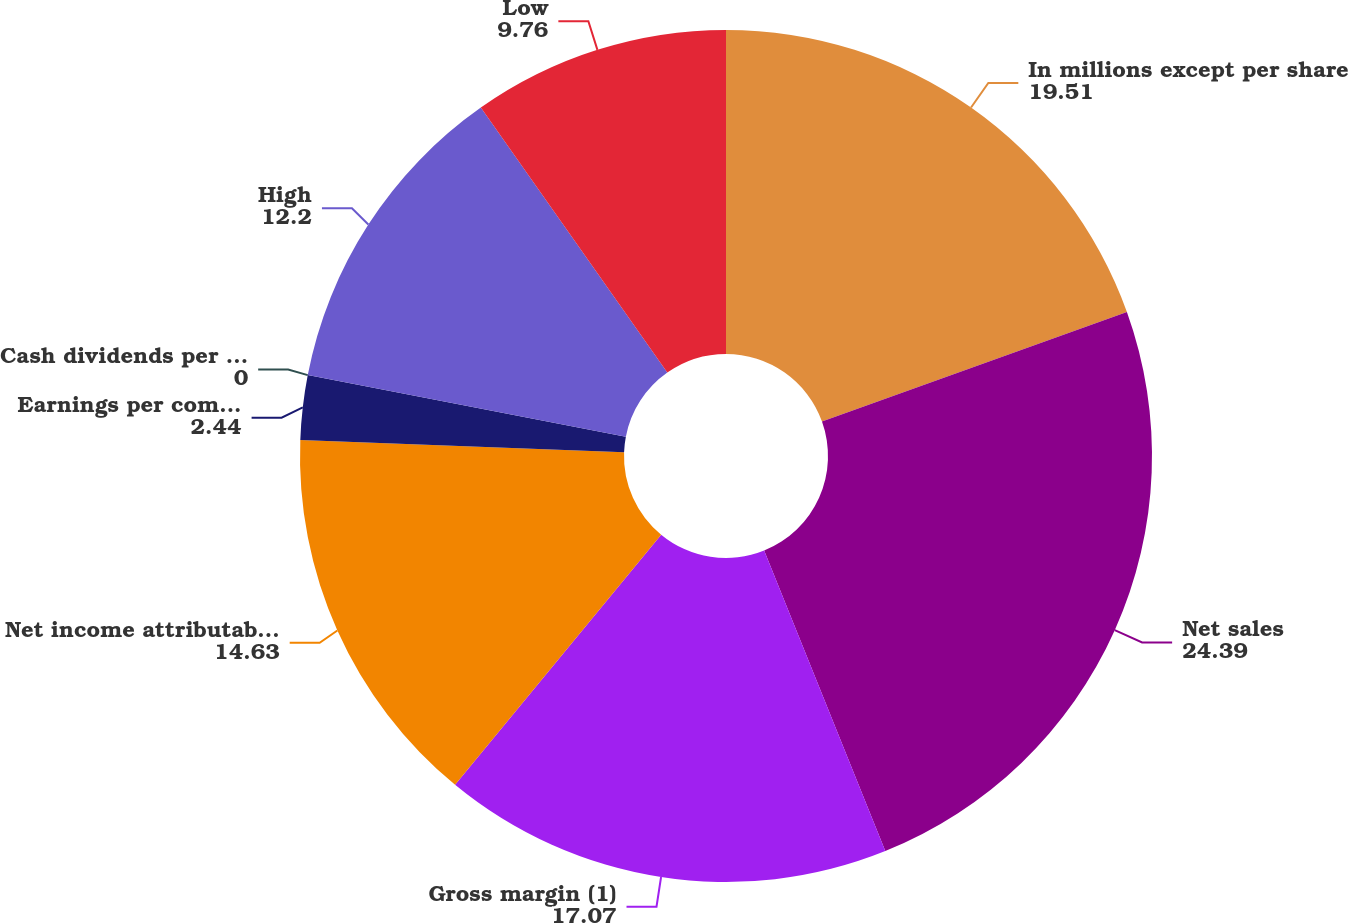Convert chart to OTSL. <chart><loc_0><loc_0><loc_500><loc_500><pie_chart><fcel>In millions except per share<fcel>Net sales<fcel>Gross margin (1)<fcel>Net income attributable to<fcel>Earnings per common share<fcel>Cash dividends per share<fcel>High<fcel>Low<nl><fcel>19.51%<fcel>24.39%<fcel>17.07%<fcel>14.63%<fcel>2.44%<fcel>0.0%<fcel>12.2%<fcel>9.76%<nl></chart> 